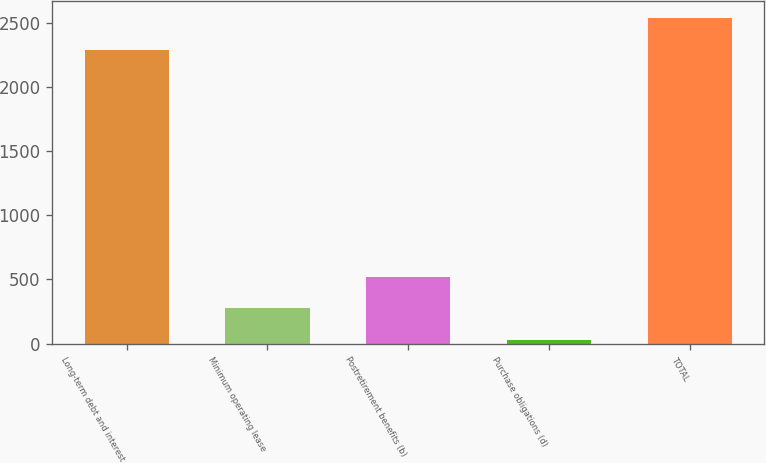Convert chart. <chart><loc_0><loc_0><loc_500><loc_500><bar_chart><fcel>Long-term debt and interest<fcel>Minimum operating lease<fcel>Postretirement benefits (b)<fcel>Purchase obligations (d)<fcel>TOTAL<nl><fcel>2290.5<fcel>273.46<fcel>522.52<fcel>24.4<fcel>2539.56<nl></chart> 